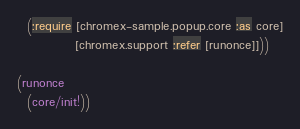<code> <loc_0><loc_0><loc_500><loc_500><_Clojure_>  (:require [chromex-sample.popup.core :as core]
            [chromex.support :refer [runonce]]))

(runonce
  (core/init!))
</code> 